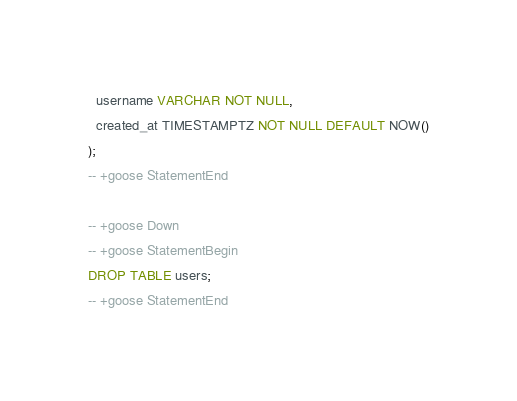Convert code to text. <code><loc_0><loc_0><loc_500><loc_500><_SQL_>  username VARCHAR NOT NULL,
  created_at TIMESTAMPTZ NOT NULL DEFAULT NOW()
);
-- +goose StatementEnd

-- +goose Down
-- +goose StatementBegin
DROP TABLE users;
-- +goose StatementEnd
</code> 